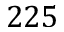<formula> <loc_0><loc_0><loc_500><loc_500>2 2 5</formula> 